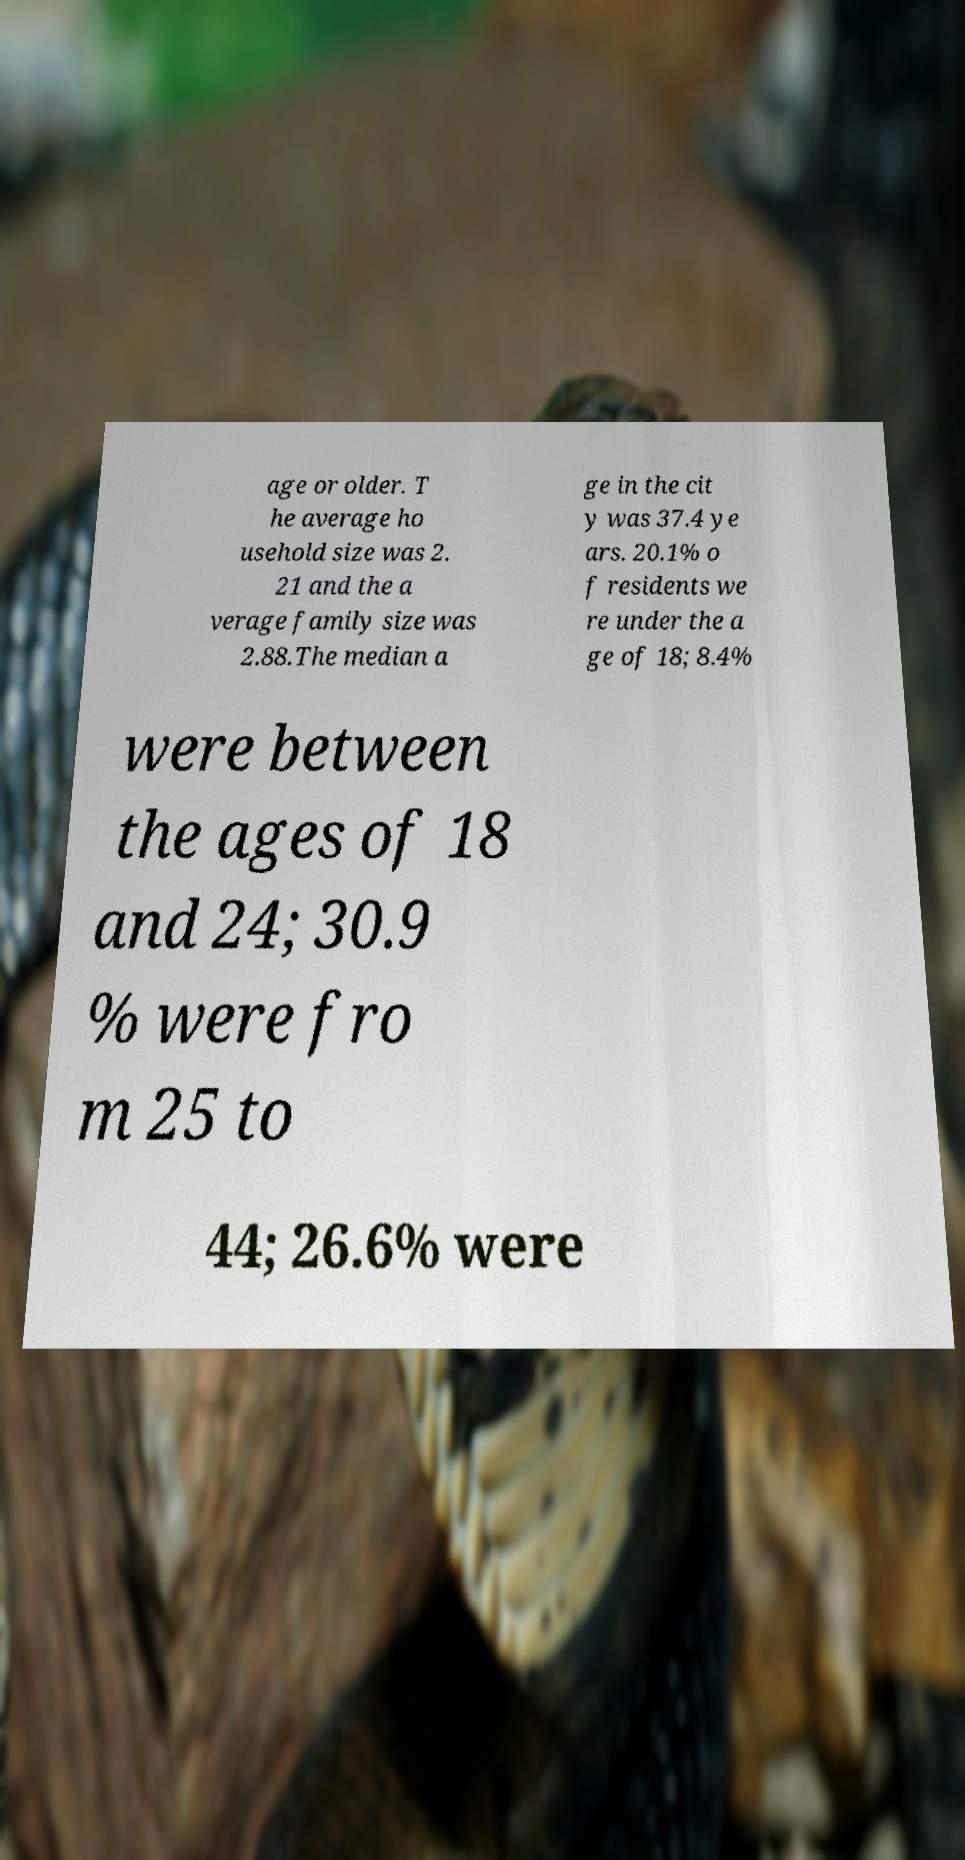Please read and relay the text visible in this image. What does it say? age or older. T he average ho usehold size was 2. 21 and the a verage family size was 2.88.The median a ge in the cit y was 37.4 ye ars. 20.1% o f residents we re under the a ge of 18; 8.4% were between the ages of 18 and 24; 30.9 % were fro m 25 to 44; 26.6% were 